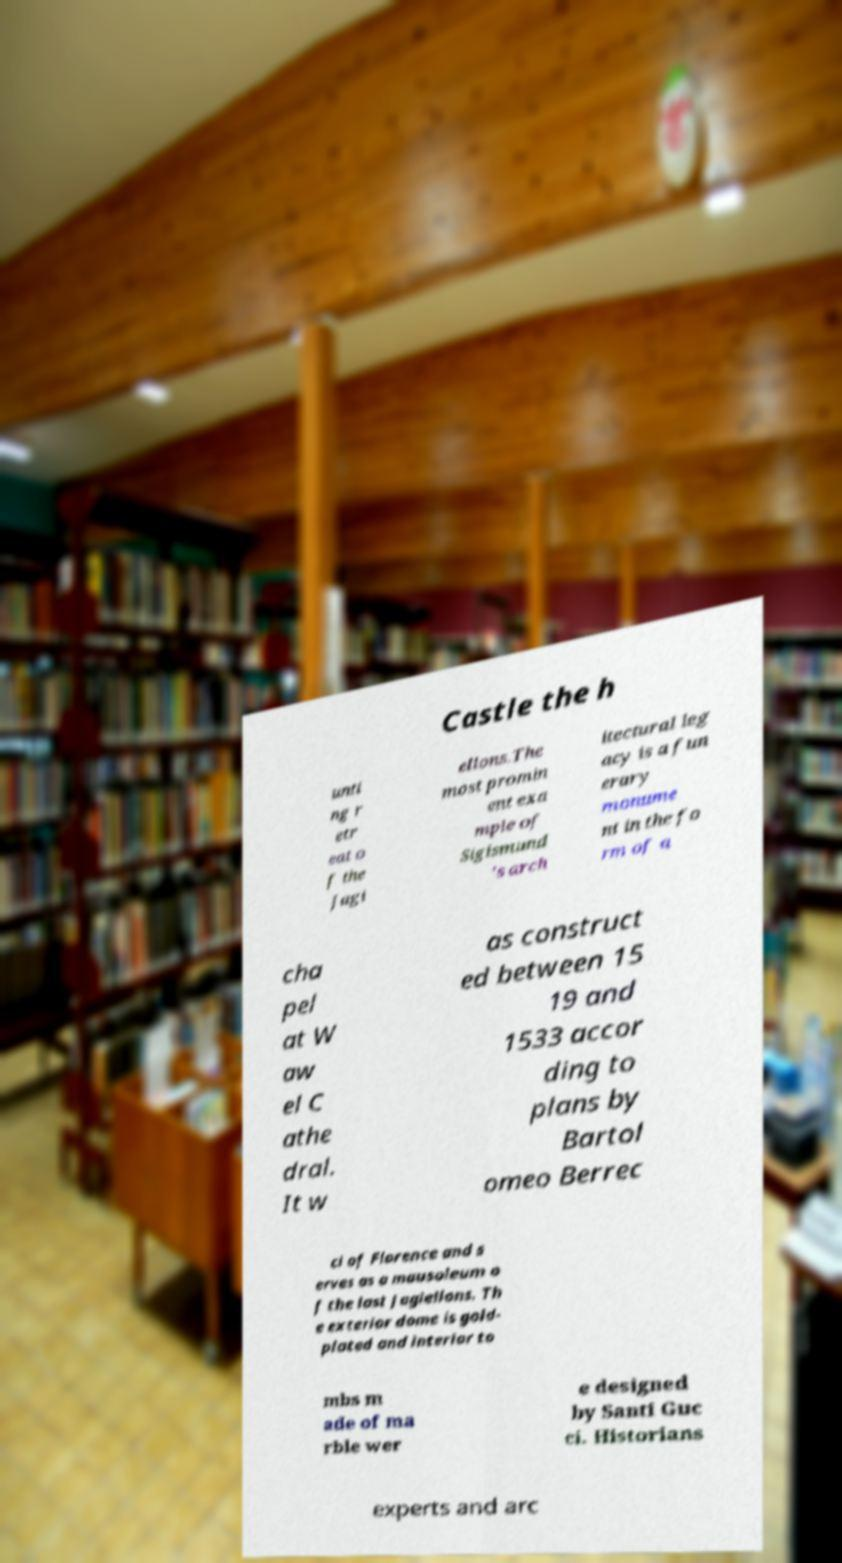Can you accurately transcribe the text from the provided image for me? Castle the h unti ng r etr eat o f the Jagi ellons.The most promin ent exa mple of Sigismund 's arch itectural leg acy is a fun erary monume nt in the fo rm of a cha pel at W aw el C athe dral. It w as construct ed between 15 19 and 1533 accor ding to plans by Bartol omeo Berrec ci of Florence and s erves as a mausoleum o f the last Jagiellons. Th e exterior dome is gold- plated and interior to mbs m ade of ma rble wer e designed by Santi Guc ci. Historians experts and arc 